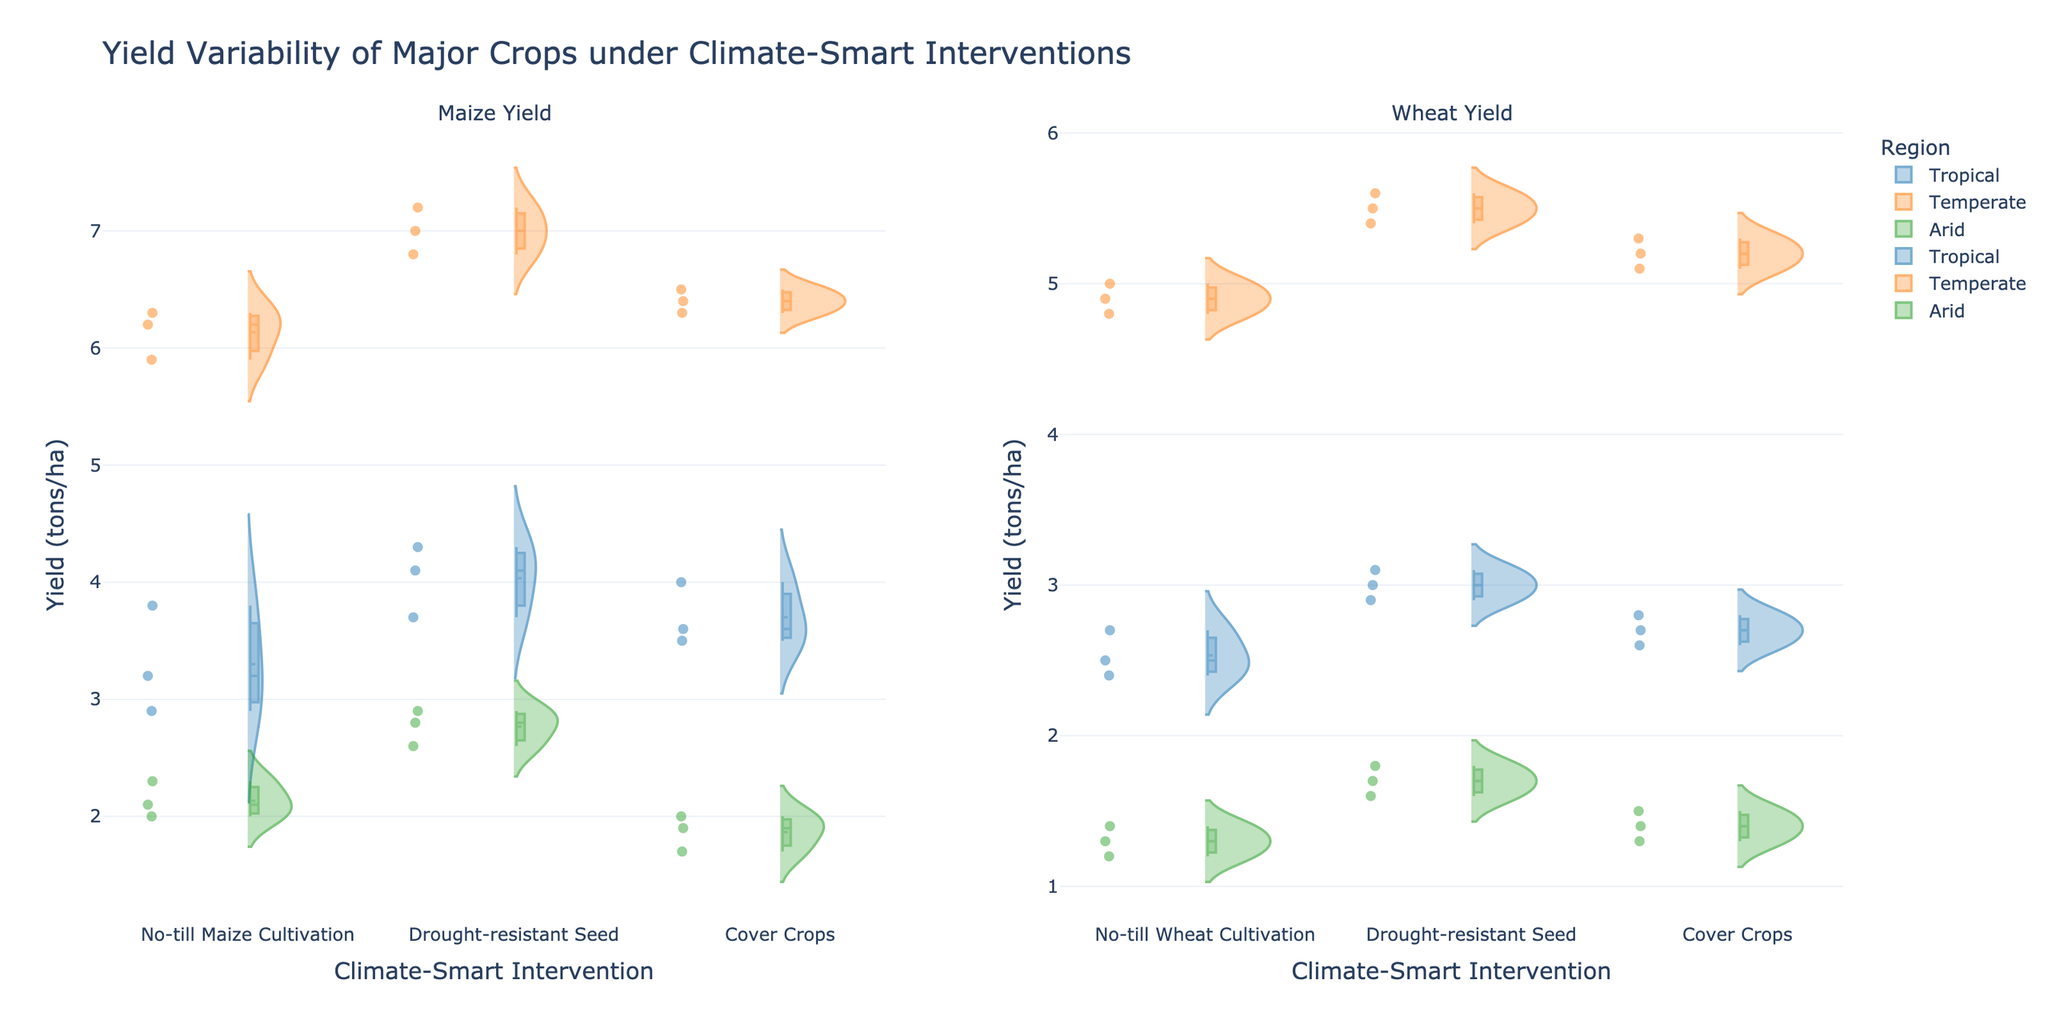What's the title of the figure? The title is usually found at the top of the figure. In this case, it reads "Yield Variability of Major Crops under Climate-Smart Interventions".
Answer: Yield Variability of Major Crops under Climate-Smart Interventions What are the two subplots in the figure? The subplot titles are usually displayed above each subplot. In this figure, they are "Maize Yield" and "Wheat Yield".
Answer: Maize Yield and Wheat Yield How are the climatic zones differentiated in the figure? The different climatic zones are differentiated by color. Each region, like Tropical, Temperate, and Arid, has a unique color. For example, Tropical might be blue, Temperate orange, and Arid green.
Answer: By color Which region shows the highest average yield for Maize under Drought-resistant Seeds? To determine this, locate the Drought-resistant Seeds intervention category under the Maize subplot and check the meanline position for each region. In this case, Temperate shows the highest mean.
Answer: Temperate Compare the yield variability of Maize under No-till Maize Cultivation in Tropical and Arid regions. For yield variability, observe the spread and width of the violins in the "No-till Maize Cultivation" category. The Tropical region has a wider violin, indicating higher variability, compared to the narrower Arid violin.
Answer: Tropical has higher variability Which intervention appears to have the smallest yield variability for Wheat in the Tropical region? Check the Wheat subplot and compare the spread and width of violins in the Tropical section. The "No-till Wheat Cultivation" violin is the narrowest, indicating the smallest variability.
Answer: No-till Wheat Cultivation What is the approximate yield range for Maize under Cover Crops in the Temperate region? Look at the Maize subplot for the "Cover Crops" category in the Temperate region. Yield values span from around 6.3 to 6.5 tons/ha.
Answer: 6.3 to 6.5 tons/ha In which region and crop combination does Cover Crops show the lowest yield range? By observing both subplots under the Cover Crops category, the Wheat subplot in the Arid region has the smallest range, from approximately 1.3 to 1.5 tons/ha.
Answer: Wheat in Arid Which intervention results in the highest average Wheat yield in the Temperate region? Look at the meanlines in the Wheat subplot for the Temperate region. The "Drought-resistant Seed" intervention has the highest meanline.
Answer: Drought-resistant Seed Is there a significant difference in Maize yield under No-till Maize Cultivation between Temperate and Arid regions? Compare the violins for "No-till Maize Cultivation" under Maize subplot. The Temperate region has a mean yield around 6.2-6.3 tons/ha, while Arid has around 2.0-2.3 tons/ha. This shows a significant difference.
Answer: Yes, significant difference 